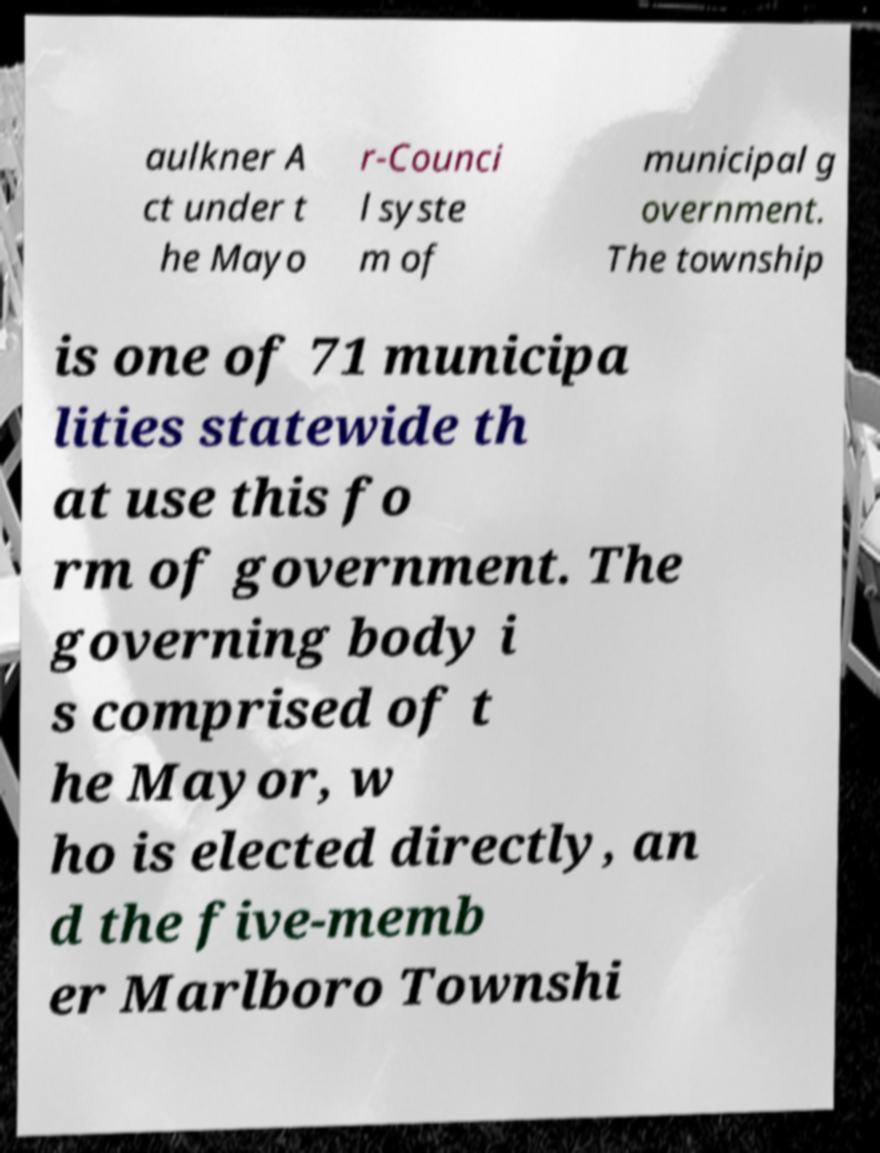What messages or text are displayed in this image? I need them in a readable, typed format. aulkner A ct under t he Mayo r-Counci l syste m of municipal g overnment. The township is one of 71 municipa lities statewide th at use this fo rm of government. The governing body i s comprised of t he Mayor, w ho is elected directly, an d the five-memb er Marlboro Townshi 